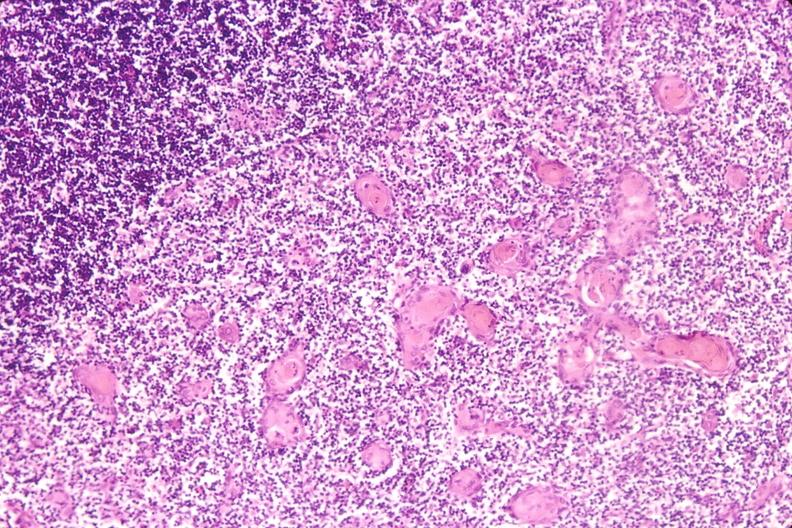do hemorrhage in newborn induce involution in baby with hyaline membrane disease?
Answer the question using a single word or phrase. No 